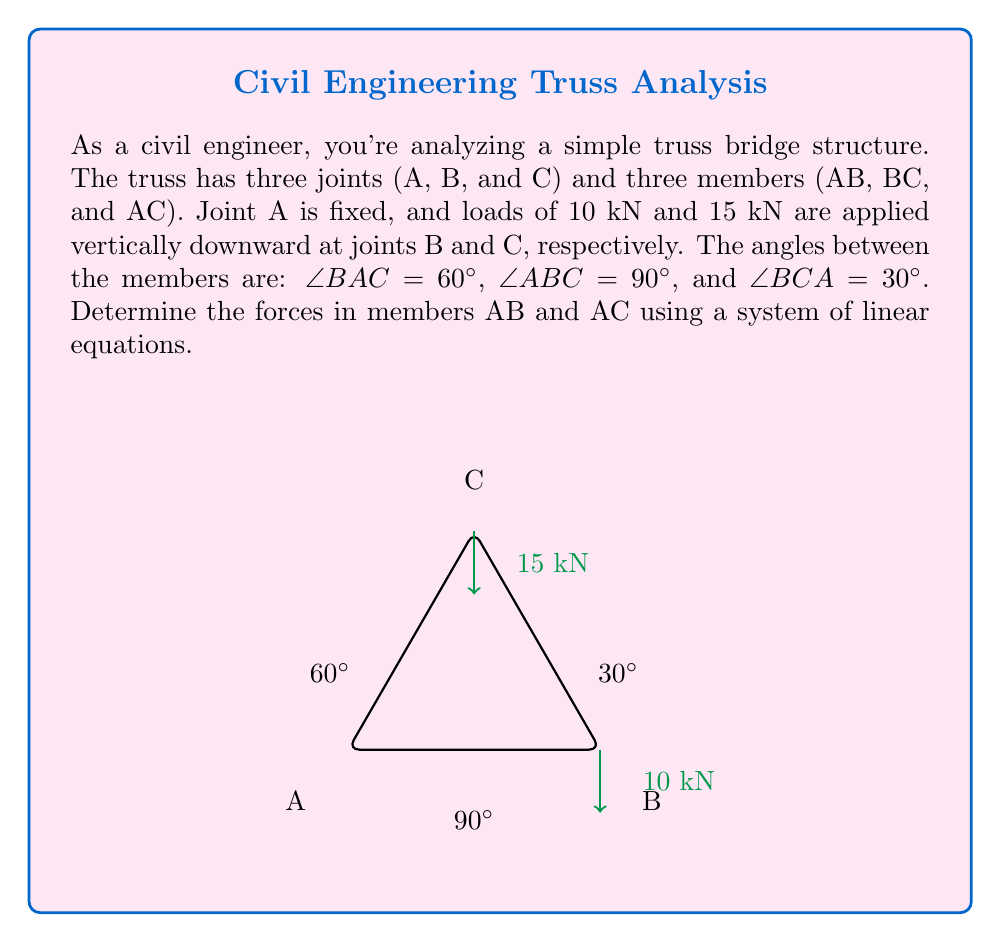Can you answer this question? To solve this problem, we'll use the method of joints and set up a system of linear equations. Let's follow these steps:

1) First, let's define our unknowns:
   Let $F_{AB}$ be the force in member AB (positive if tensile)
   Let $F_{AC}$ be the force in member AC (positive if tensile)

2) Now, let's consider the equilibrium of joint B:
   Vertical equilibrium: $F_{AB} - 10 = 0$
   Horizontal equilibrium: $F_{BC} = 0$ (no horizontal external force)

   From this, we can conclude that $F_{AB} = 10$ kN (tensile)

3) Next, let's consider the equilibrium of joint C:
   We'll set up equations for both vertical and horizontal equilibrium:

   Vertical: $F_{AC} \sin 60° - 15 = 0$
   Horizontal: $F_{AC} \cos 60° - F_{BC} = 0$

4) We can simplify these equations:
   Vertical: $F_{AC} \cdot \frac{\sqrt{3}}{2} - 15 = 0$
   Horizontal: $F_{AC} \cdot \frac{1}{2} - F_{BC} = 0$

5) From the vertical equation:
   $F_{AC} \cdot \frac{\sqrt{3}}{2} = 15$
   $F_{AC} = \frac{15 \cdot 2}{\sqrt{3}} = \frac{30}{\sqrt{3}} = 10\sqrt{3}$ kN

6) We can then find $F_{BC}$ from the horizontal equation:
   $F_{BC} = F_{AC} \cdot \frac{1}{2} = 5\sqrt{3}$ kN

Thus, our system of linear equations has led us to the solutions for $F_{AB}$ and $F_{AC}$.
Answer: $F_{AB} = 10$ kN (tensile)
$F_{AC} = 10\sqrt{3}$ kN (tensile) 